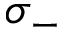<formula> <loc_0><loc_0><loc_500><loc_500>\sigma _ { - }</formula> 